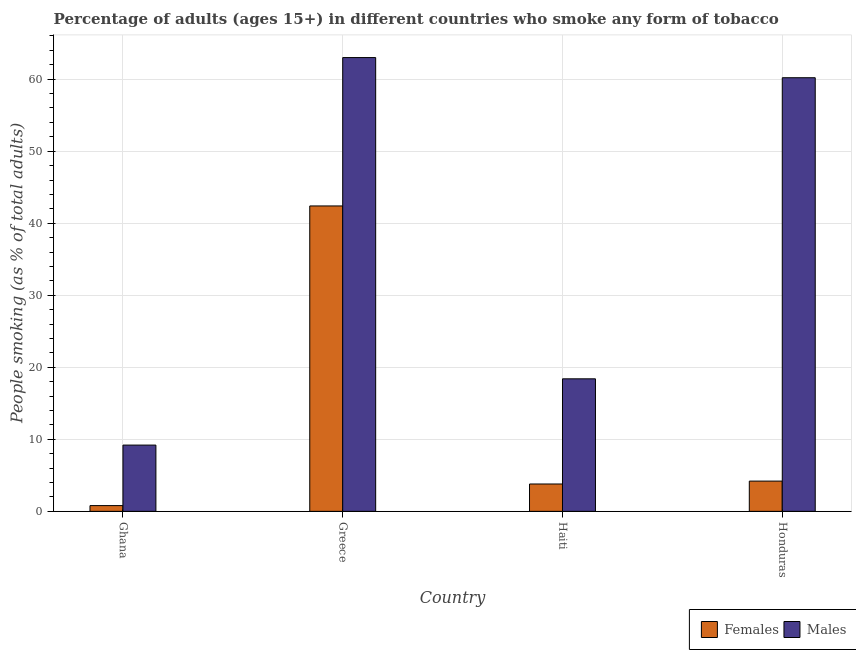How many groups of bars are there?
Ensure brevity in your answer.  4. Are the number of bars per tick equal to the number of legend labels?
Your answer should be very brief. Yes. How many bars are there on the 1st tick from the left?
Your response must be concise. 2. What is the label of the 4th group of bars from the left?
Offer a terse response. Honduras. Across all countries, what is the maximum percentage of males who smoke?
Provide a short and direct response. 63. Across all countries, what is the minimum percentage of females who smoke?
Offer a very short reply. 0.8. What is the total percentage of females who smoke in the graph?
Your response must be concise. 51.2. What is the difference between the percentage of males who smoke in Greece and that in Haiti?
Keep it short and to the point. 44.6. What is the difference between the percentage of males who smoke in Ghana and the percentage of females who smoke in Greece?
Your answer should be very brief. -33.2. What is the average percentage of females who smoke per country?
Give a very brief answer. 12.8. What is the difference between the percentage of males who smoke and percentage of females who smoke in Greece?
Provide a short and direct response. 20.6. What is the ratio of the percentage of females who smoke in Ghana to that in Honduras?
Give a very brief answer. 0.19. Is the percentage of females who smoke in Ghana less than that in Greece?
Your answer should be compact. Yes. What is the difference between the highest and the second highest percentage of females who smoke?
Provide a succinct answer. 38.2. What is the difference between the highest and the lowest percentage of males who smoke?
Offer a very short reply. 53.8. Is the sum of the percentage of males who smoke in Ghana and Honduras greater than the maximum percentage of females who smoke across all countries?
Give a very brief answer. Yes. What does the 1st bar from the left in Greece represents?
Your answer should be compact. Females. What does the 2nd bar from the right in Haiti represents?
Offer a very short reply. Females. How many bars are there?
Ensure brevity in your answer.  8. How many countries are there in the graph?
Offer a terse response. 4. What is the difference between two consecutive major ticks on the Y-axis?
Your answer should be compact. 10. Does the graph contain any zero values?
Offer a very short reply. No. Where does the legend appear in the graph?
Provide a succinct answer. Bottom right. How are the legend labels stacked?
Make the answer very short. Horizontal. What is the title of the graph?
Provide a succinct answer. Percentage of adults (ages 15+) in different countries who smoke any form of tobacco. What is the label or title of the X-axis?
Offer a terse response. Country. What is the label or title of the Y-axis?
Ensure brevity in your answer.  People smoking (as % of total adults). What is the People smoking (as % of total adults) of Males in Ghana?
Your response must be concise. 9.2. What is the People smoking (as % of total adults) of Females in Greece?
Give a very brief answer. 42.4. What is the People smoking (as % of total adults) in Males in Greece?
Provide a short and direct response. 63. What is the People smoking (as % of total adults) of Females in Haiti?
Ensure brevity in your answer.  3.8. What is the People smoking (as % of total adults) of Females in Honduras?
Keep it short and to the point. 4.2. What is the People smoking (as % of total adults) of Males in Honduras?
Offer a terse response. 60.2. Across all countries, what is the maximum People smoking (as % of total adults) of Females?
Offer a terse response. 42.4. Across all countries, what is the maximum People smoking (as % of total adults) of Males?
Offer a terse response. 63. What is the total People smoking (as % of total adults) in Females in the graph?
Your answer should be very brief. 51.2. What is the total People smoking (as % of total adults) in Males in the graph?
Ensure brevity in your answer.  150.8. What is the difference between the People smoking (as % of total adults) in Females in Ghana and that in Greece?
Your response must be concise. -41.6. What is the difference between the People smoking (as % of total adults) of Males in Ghana and that in Greece?
Keep it short and to the point. -53.8. What is the difference between the People smoking (as % of total adults) of Males in Ghana and that in Haiti?
Your response must be concise. -9.2. What is the difference between the People smoking (as % of total adults) of Females in Ghana and that in Honduras?
Make the answer very short. -3.4. What is the difference between the People smoking (as % of total adults) of Males in Ghana and that in Honduras?
Offer a very short reply. -51. What is the difference between the People smoking (as % of total adults) in Females in Greece and that in Haiti?
Provide a succinct answer. 38.6. What is the difference between the People smoking (as % of total adults) of Males in Greece and that in Haiti?
Make the answer very short. 44.6. What is the difference between the People smoking (as % of total adults) of Females in Greece and that in Honduras?
Provide a succinct answer. 38.2. What is the difference between the People smoking (as % of total adults) in Females in Haiti and that in Honduras?
Your answer should be very brief. -0.4. What is the difference between the People smoking (as % of total adults) of Males in Haiti and that in Honduras?
Offer a terse response. -41.8. What is the difference between the People smoking (as % of total adults) in Females in Ghana and the People smoking (as % of total adults) in Males in Greece?
Ensure brevity in your answer.  -62.2. What is the difference between the People smoking (as % of total adults) of Females in Ghana and the People smoking (as % of total adults) of Males in Haiti?
Ensure brevity in your answer.  -17.6. What is the difference between the People smoking (as % of total adults) of Females in Ghana and the People smoking (as % of total adults) of Males in Honduras?
Your answer should be compact. -59.4. What is the difference between the People smoking (as % of total adults) in Females in Greece and the People smoking (as % of total adults) in Males in Honduras?
Your response must be concise. -17.8. What is the difference between the People smoking (as % of total adults) of Females in Haiti and the People smoking (as % of total adults) of Males in Honduras?
Make the answer very short. -56.4. What is the average People smoking (as % of total adults) in Females per country?
Give a very brief answer. 12.8. What is the average People smoking (as % of total adults) of Males per country?
Provide a short and direct response. 37.7. What is the difference between the People smoking (as % of total adults) of Females and People smoking (as % of total adults) of Males in Ghana?
Give a very brief answer. -8.4. What is the difference between the People smoking (as % of total adults) of Females and People smoking (as % of total adults) of Males in Greece?
Provide a short and direct response. -20.6. What is the difference between the People smoking (as % of total adults) of Females and People smoking (as % of total adults) of Males in Haiti?
Your answer should be compact. -14.6. What is the difference between the People smoking (as % of total adults) of Females and People smoking (as % of total adults) of Males in Honduras?
Keep it short and to the point. -56. What is the ratio of the People smoking (as % of total adults) in Females in Ghana to that in Greece?
Provide a short and direct response. 0.02. What is the ratio of the People smoking (as % of total adults) of Males in Ghana to that in Greece?
Offer a terse response. 0.15. What is the ratio of the People smoking (as % of total adults) in Females in Ghana to that in Haiti?
Offer a very short reply. 0.21. What is the ratio of the People smoking (as % of total adults) of Males in Ghana to that in Haiti?
Provide a short and direct response. 0.5. What is the ratio of the People smoking (as % of total adults) of Females in Ghana to that in Honduras?
Make the answer very short. 0.19. What is the ratio of the People smoking (as % of total adults) of Males in Ghana to that in Honduras?
Provide a short and direct response. 0.15. What is the ratio of the People smoking (as % of total adults) of Females in Greece to that in Haiti?
Keep it short and to the point. 11.16. What is the ratio of the People smoking (as % of total adults) in Males in Greece to that in Haiti?
Make the answer very short. 3.42. What is the ratio of the People smoking (as % of total adults) in Females in Greece to that in Honduras?
Your response must be concise. 10.1. What is the ratio of the People smoking (as % of total adults) of Males in Greece to that in Honduras?
Your answer should be compact. 1.05. What is the ratio of the People smoking (as % of total adults) in Females in Haiti to that in Honduras?
Your answer should be compact. 0.9. What is the ratio of the People smoking (as % of total adults) in Males in Haiti to that in Honduras?
Offer a terse response. 0.31. What is the difference between the highest and the second highest People smoking (as % of total adults) of Females?
Offer a terse response. 38.2. What is the difference between the highest and the lowest People smoking (as % of total adults) in Females?
Offer a very short reply. 41.6. What is the difference between the highest and the lowest People smoking (as % of total adults) in Males?
Your answer should be very brief. 53.8. 